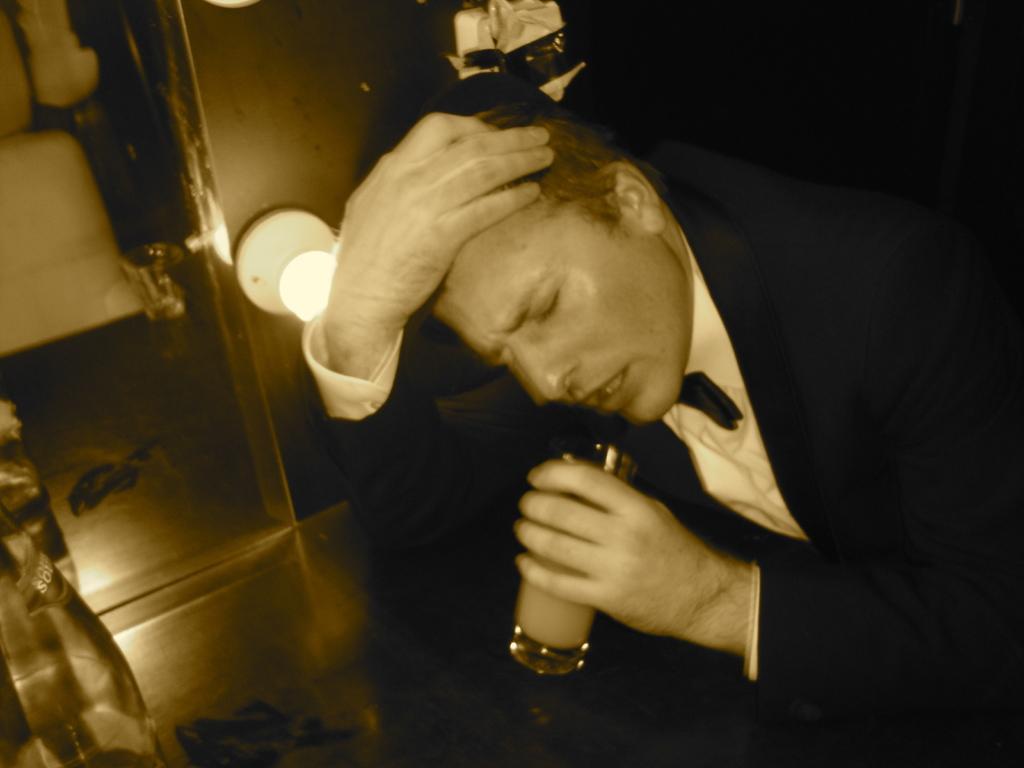Please provide a concise description of this image. In this image I can see a person holding a glass and the person is wearing black blazer, white shirt. Background I can see a light. 